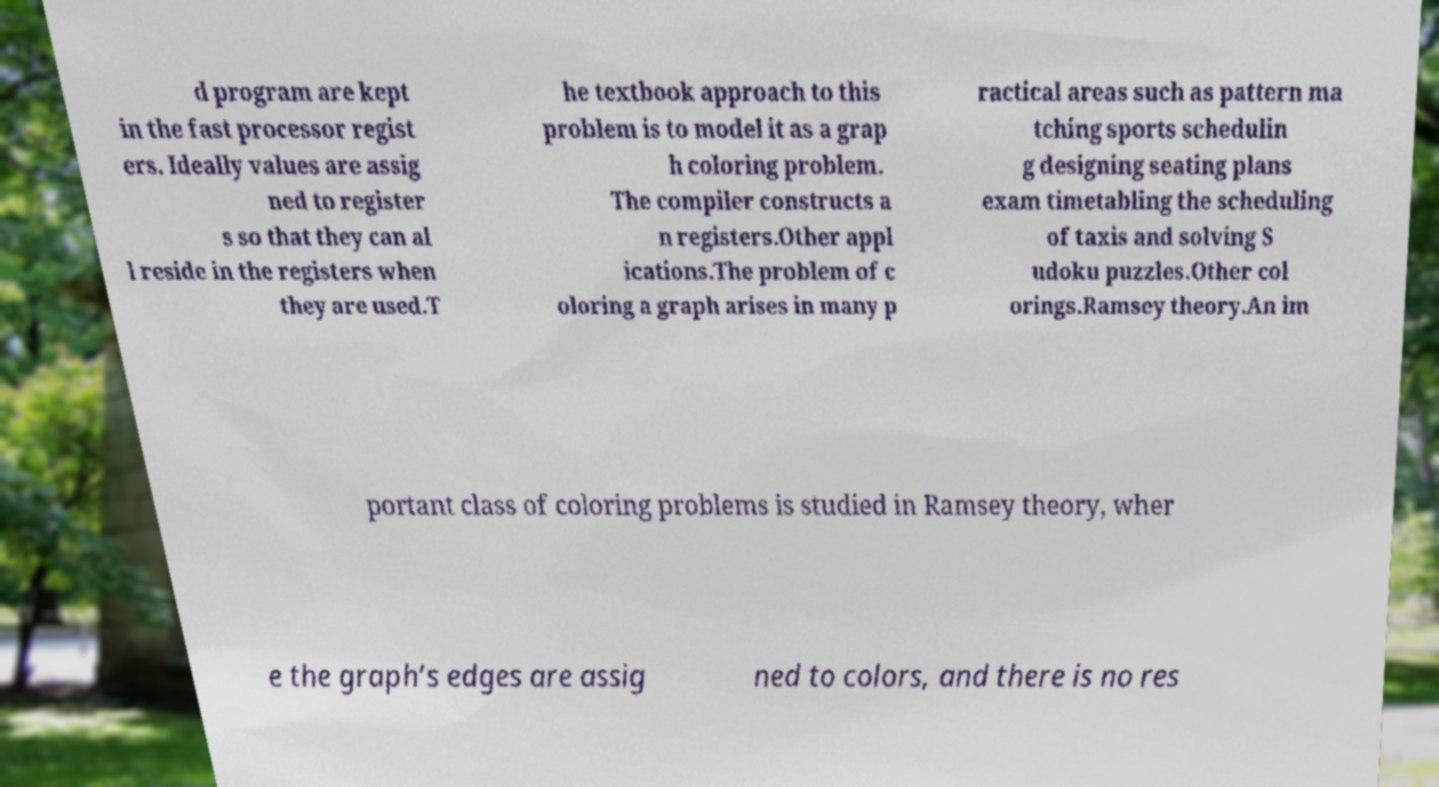For documentation purposes, I need the text within this image transcribed. Could you provide that? d program are kept in the fast processor regist ers. Ideally values are assig ned to register s so that they can al l reside in the registers when they are used.T he textbook approach to this problem is to model it as a grap h coloring problem. The compiler constructs a n registers.Other appl ications.The problem of c oloring a graph arises in many p ractical areas such as pattern ma tching sports schedulin g designing seating plans exam timetabling the scheduling of taxis and solving S udoku puzzles.Other col orings.Ramsey theory.An im portant class of coloring problems is studied in Ramsey theory, wher e the graph’s edges are assig ned to colors, and there is no res 